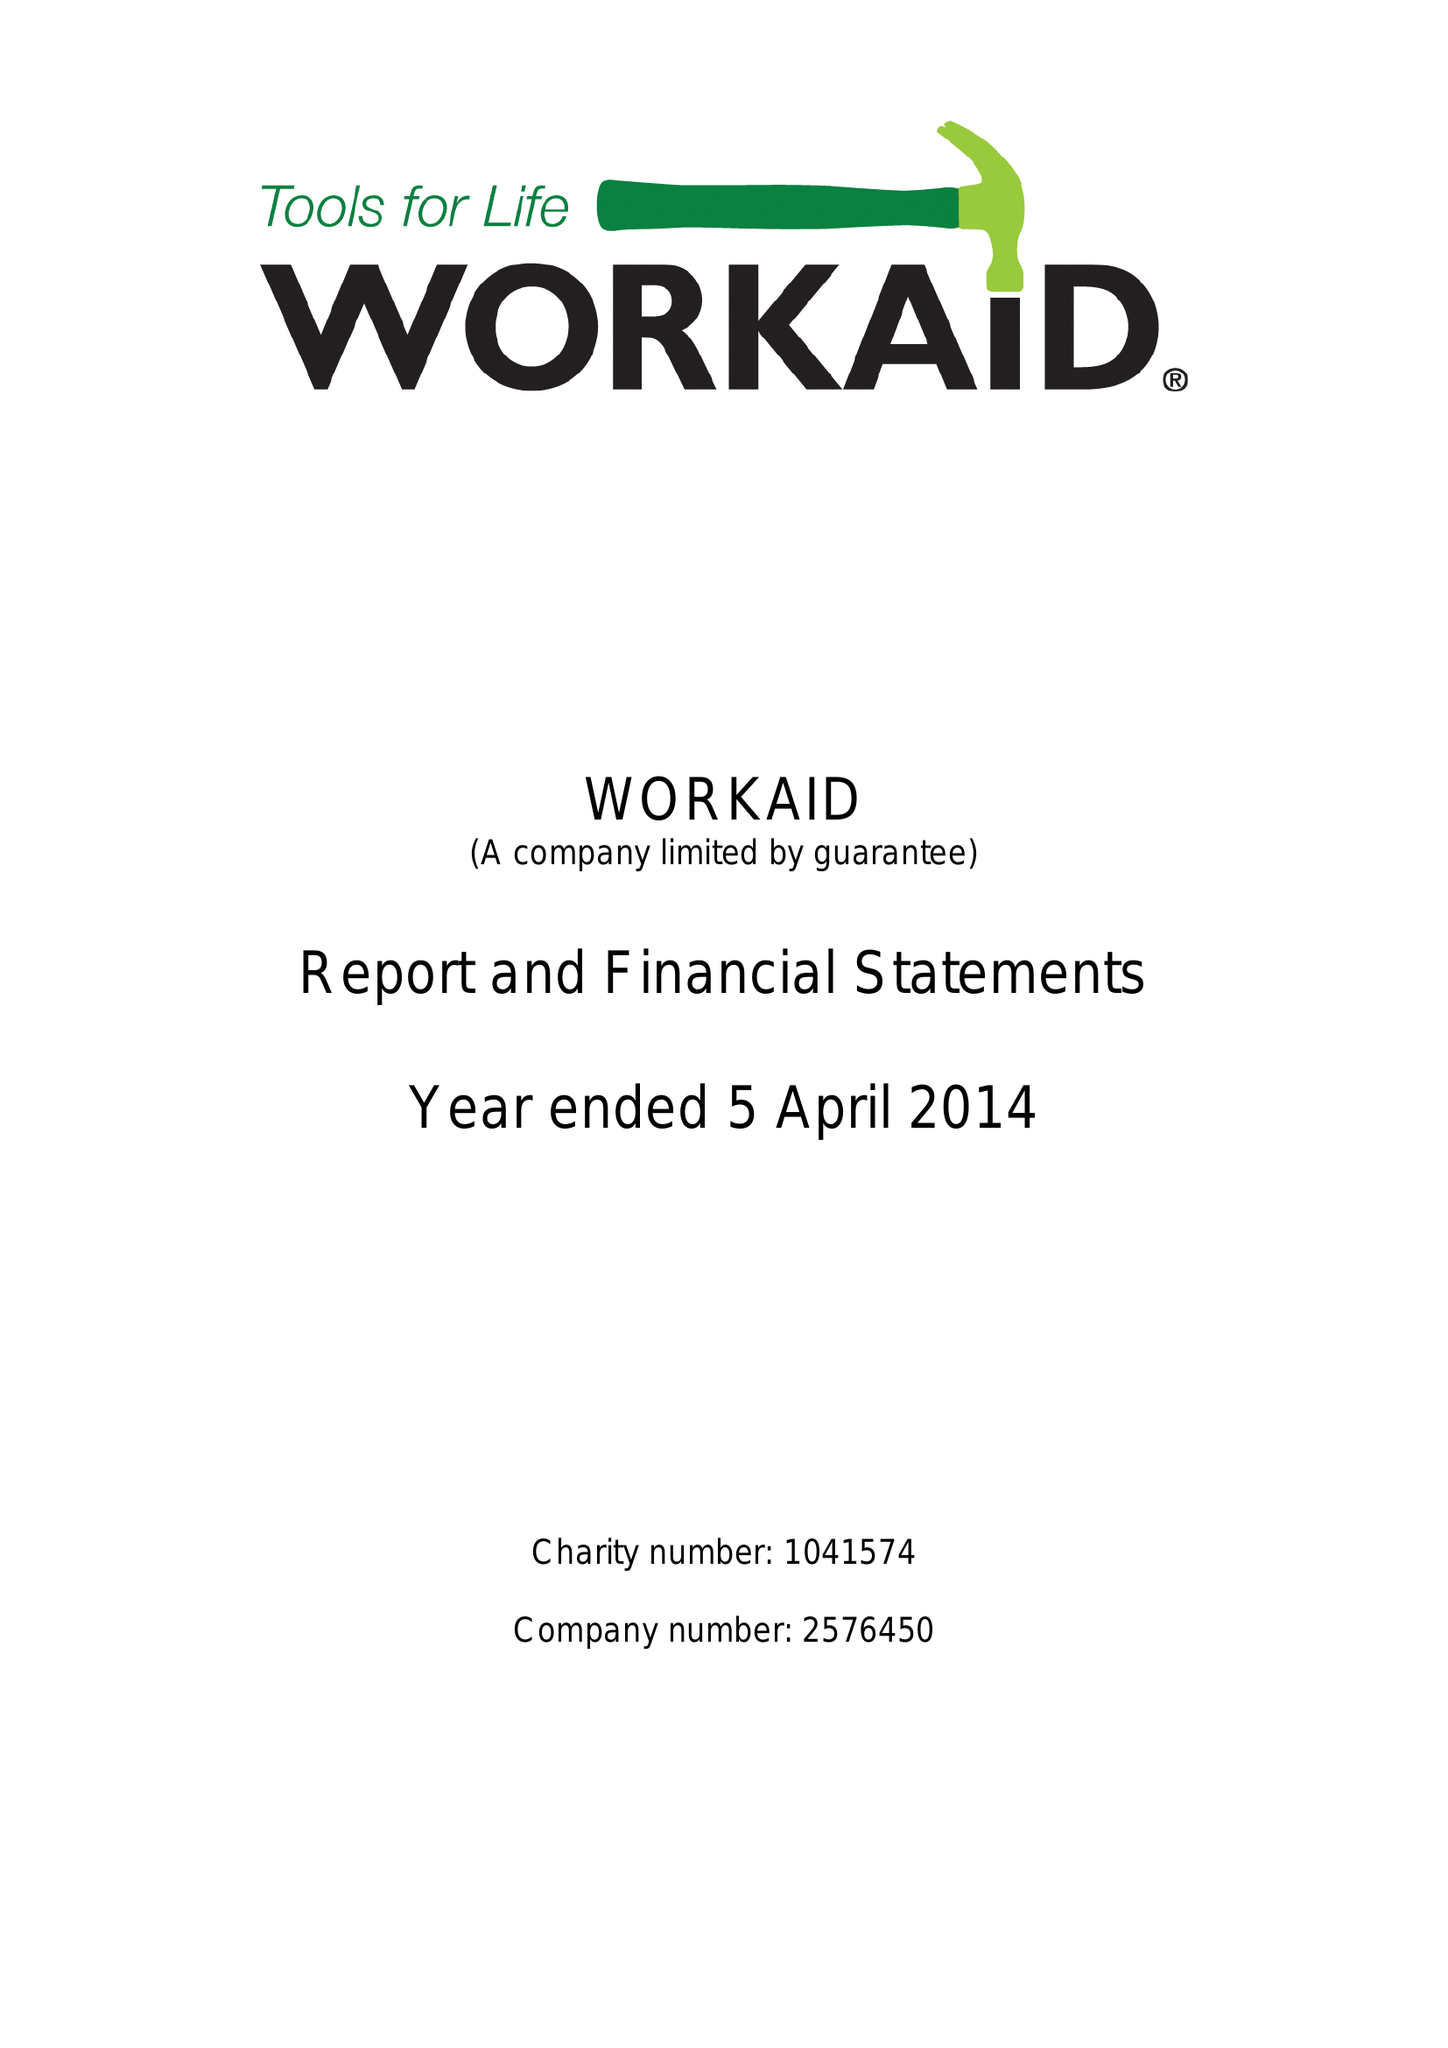What is the value for the address__street_line?
Answer the question using a single word or phrase. 71 TOWNSEND ROAD 